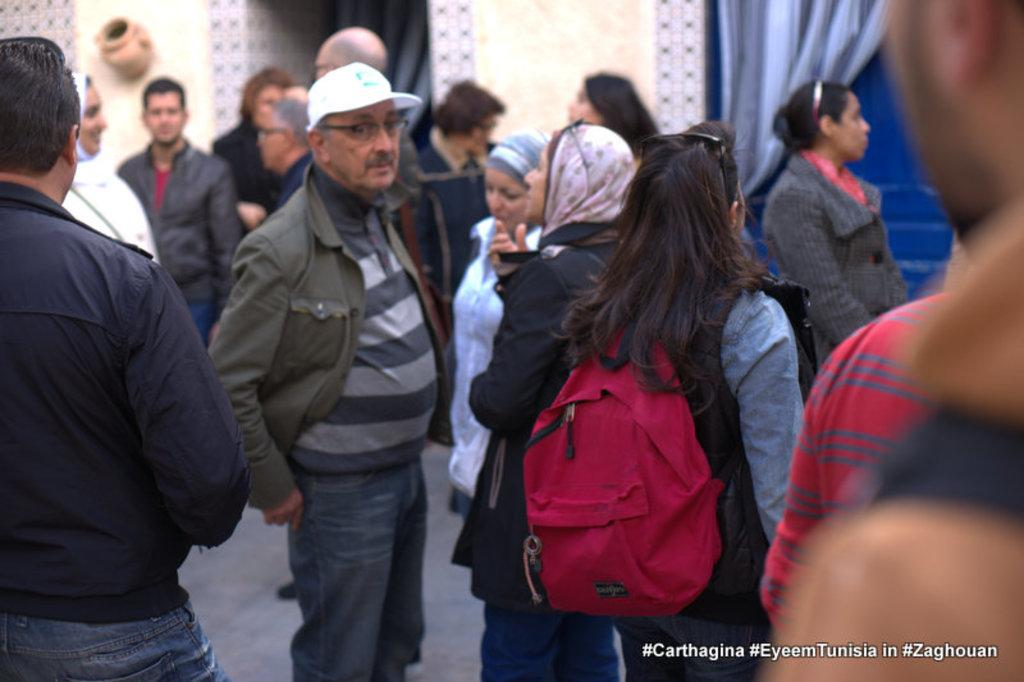How many people are in the image? There is a group of people in the image. Can you describe the clothing of one of the individuals? One person is wearing a red color bag. What is the color of the wall in the background? There is a white wall in the background. What other element can be seen in the background? There is a blue curtain in the background. What type of crow is sitting on the actor's shoulder in the image? There is no crow or actor present in the image. 